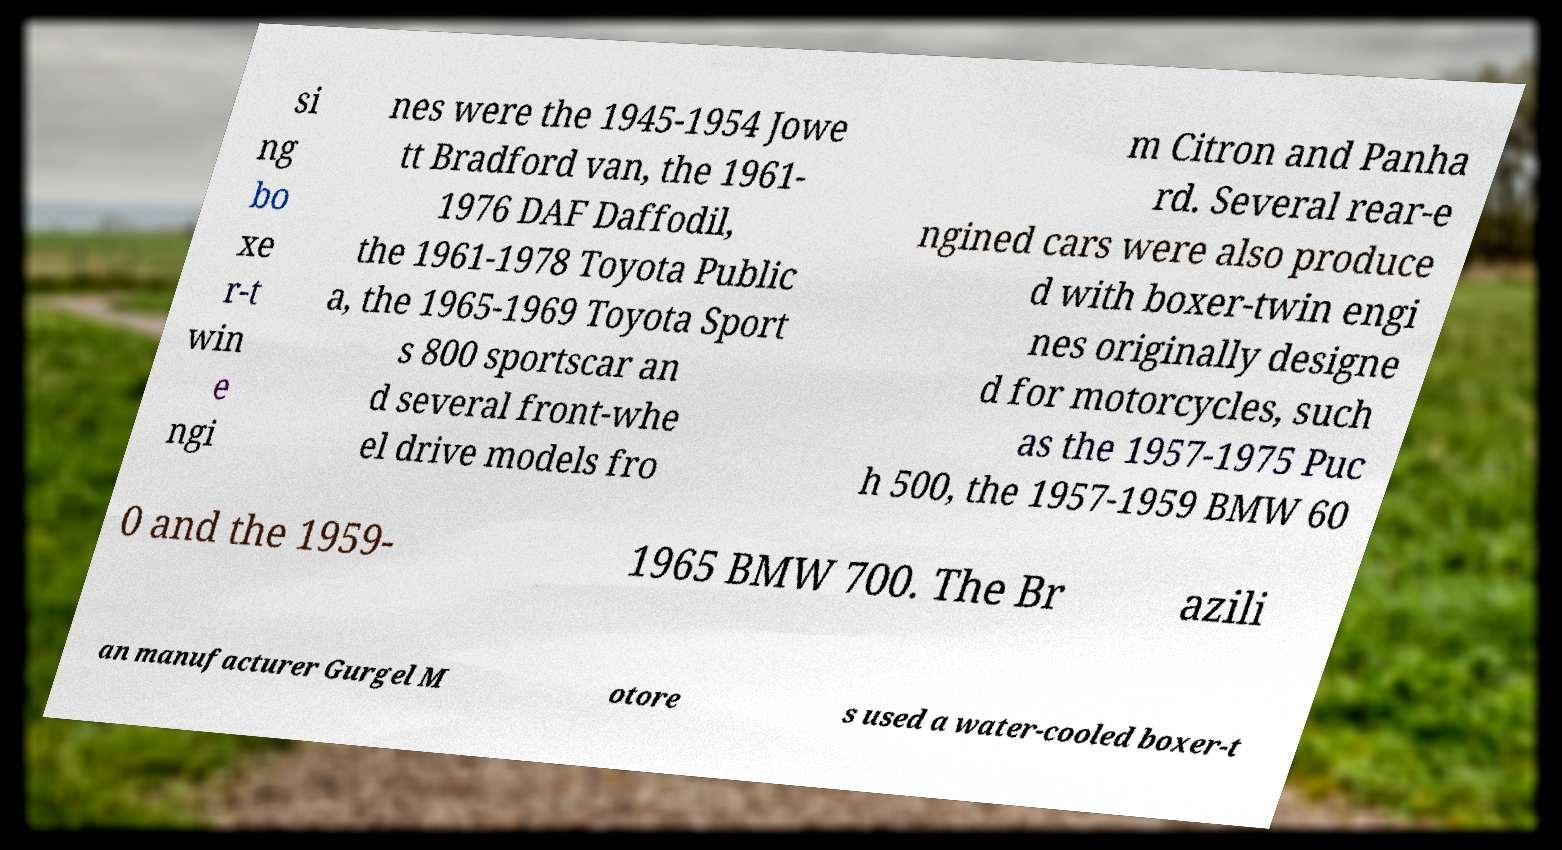Could you assist in decoding the text presented in this image and type it out clearly? si ng bo xe r-t win e ngi nes were the 1945-1954 Jowe tt Bradford van, the 1961- 1976 DAF Daffodil, the 1961-1978 Toyota Public a, the 1965-1969 Toyota Sport s 800 sportscar an d several front-whe el drive models fro m Citron and Panha rd. Several rear-e ngined cars were also produce d with boxer-twin engi nes originally designe d for motorcycles, such as the 1957-1975 Puc h 500, the 1957-1959 BMW 60 0 and the 1959- 1965 BMW 700. The Br azili an manufacturer Gurgel M otore s used a water-cooled boxer-t 